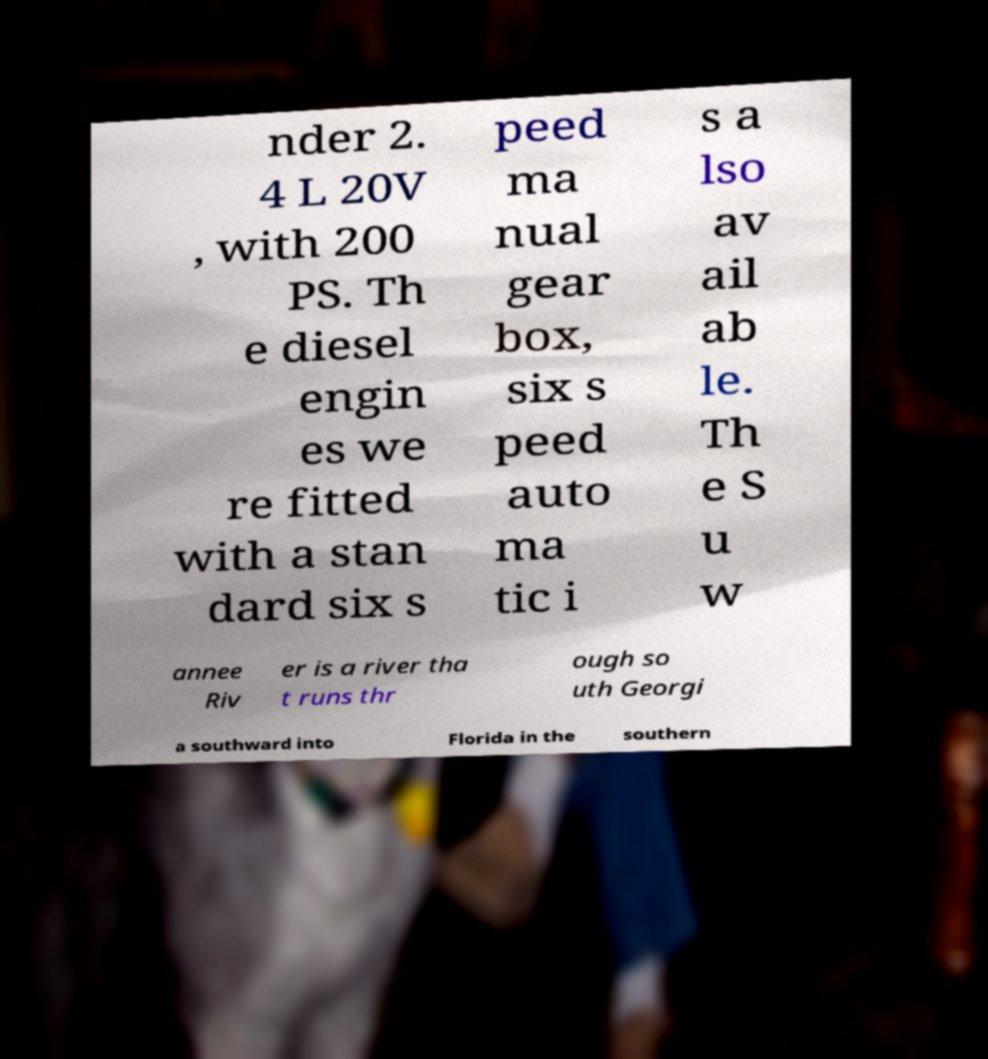For documentation purposes, I need the text within this image transcribed. Could you provide that? nder 2. 4 L 20V , with 200 PS. Th e diesel engin es we re fitted with a stan dard six s peed ma nual gear box, six s peed auto ma tic i s a lso av ail ab le. Th e S u w annee Riv er is a river tha t runs thr ough so uth Georgi a southward into Florida in the southern 